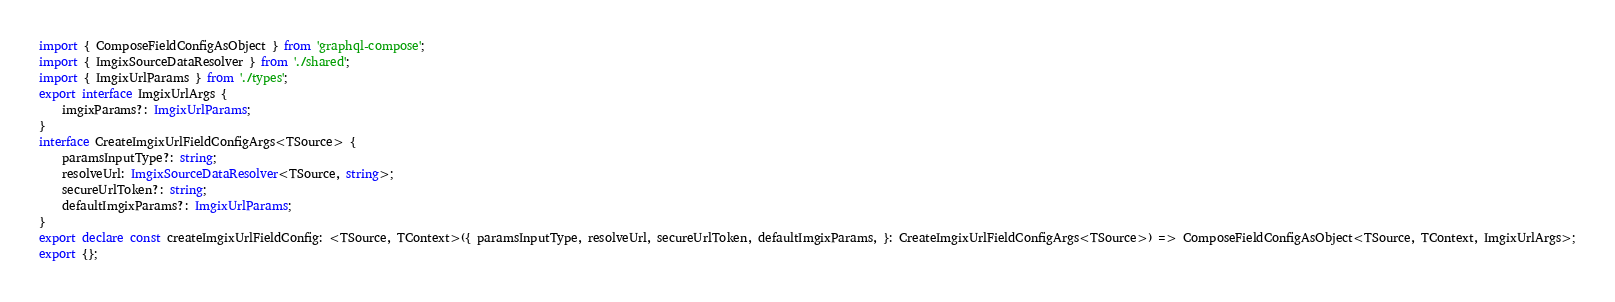<code> <loc_0><loc_0><loc_500><loc_500><_TypeScript_>import { ComposeFieldConfigAsObject } from 'graphql-compose';
import { ImgixSourceDataResolver } from './shared';
import { ImgixUrlParams } from './types';
export interface ImgixUrlArgs {
    imgixParams?: ImgixUrlParams;
}
interface CreateImgixUrlFieldConfigArgs<TSource> {
    paramsInputType?: string;
    resolveUrl: ImgixSourceDataResolver<TSource, string>;
    secureUrlToken?: string;
    defaultImgixParams?: ImgixUrlParams;
}
export declare const createImgixUrlFieldConfig: <TSource, TContext>({ paramsInputType, resolveUrl, secureUrlToken, defaultImgixParams, }: CreateImgixUrlFieldConfigArgs<TSource>) => ComposeFieldConfigAsObject<TSource, TContext, ImgixUrlArgs>;
export {};
</code> 